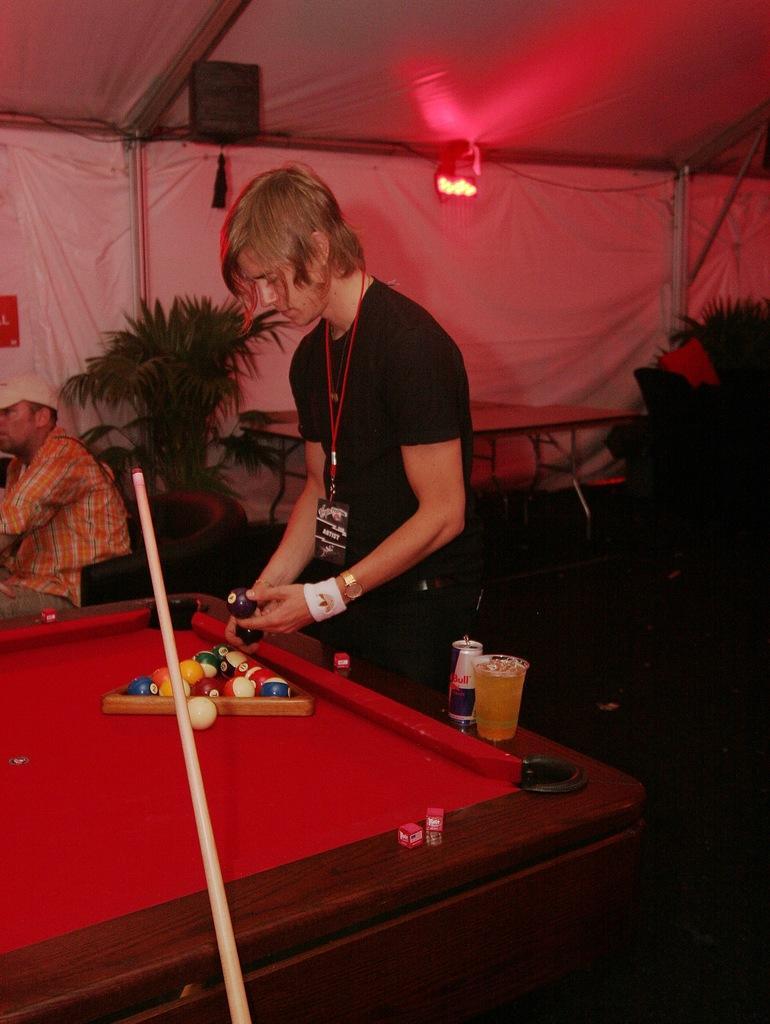How would you summarize this image in a sentence or two? In this image we can see a person holding the balls, in front of him we can see a board with some balls, glasses and some other objects, also we can see a person sitting on the chair, there are some plants and lights. 